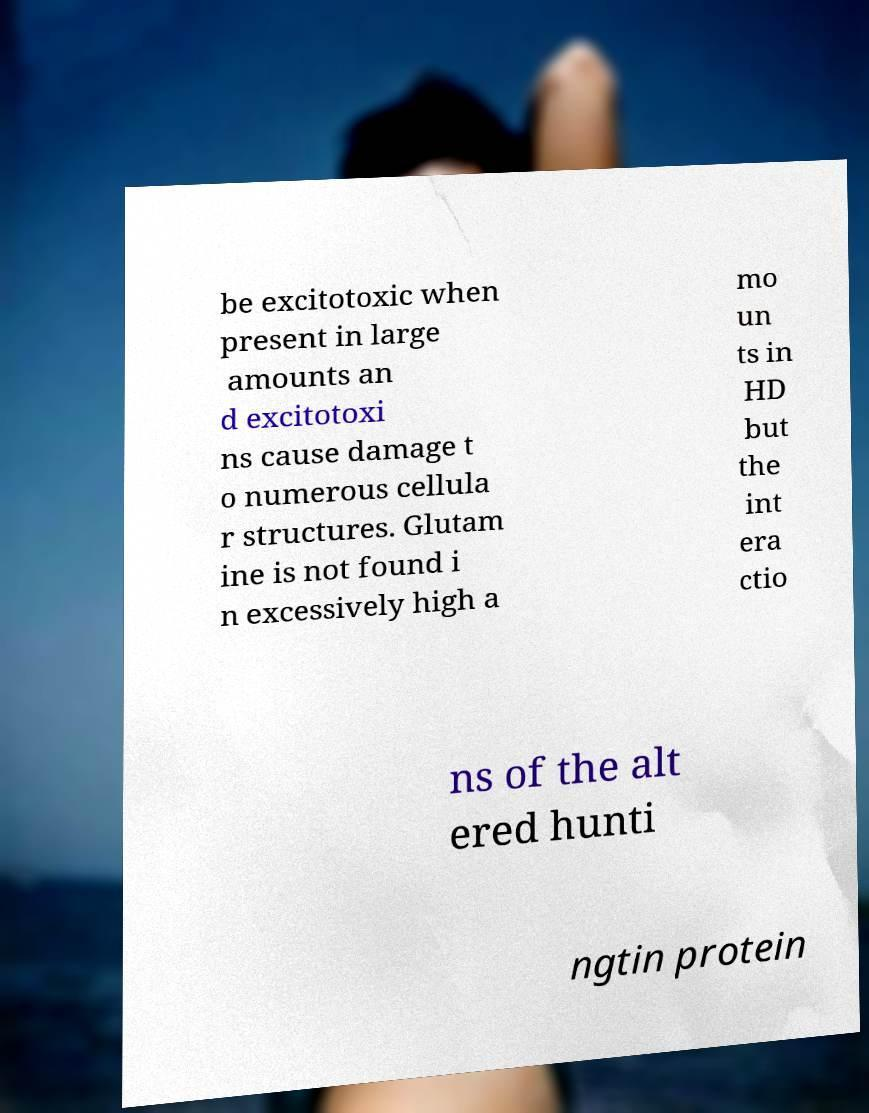For documentation purposes, I need the text within this image transcribed. Could you provide that? be excitotoxic when present in large amounts an d excitotoxi ns cause damage t o numerous cellula r structures. Glutam ine is not found i n excessively high a mo un ts in HD but the int era ctio ns of the alt ered hunti ngtin protein 